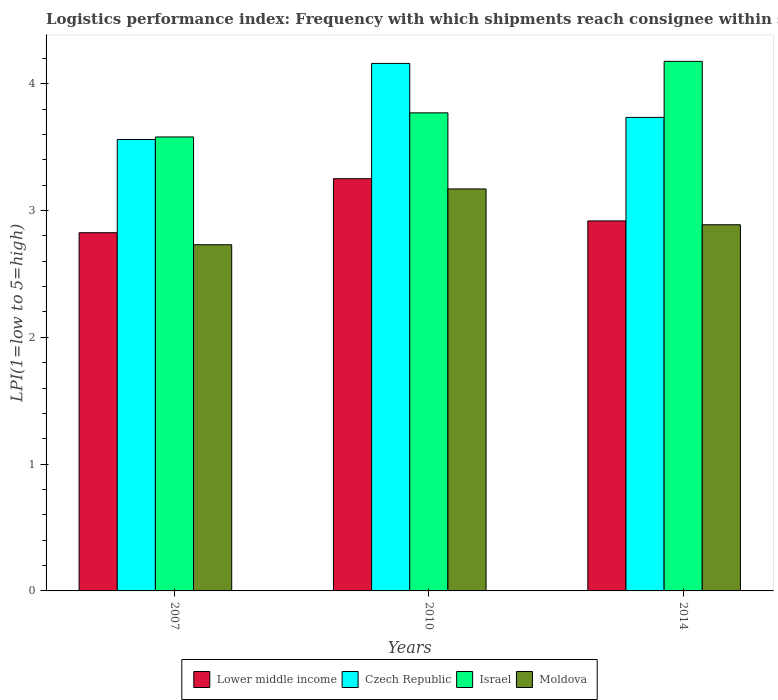How many groups of bars are there?
Your answer should be compact. 3. Are the number of bars per tick equal to the number of legend labels?
Make the answer very short. Yes. Are the number of bars on each tick of the X-axis equal?
Provide a short and direct response. Yes. What is the label of the 1st group of bars from the left?
Offer a terse response. 2007. What is the logistics performance index in Lower middle income in 2014?
Your answer should be compact. 2.92. Across all years, what is the maximum logistics performance index in Lower middle income?
Your response must be concise. 3.25. Across all years, what is the minimum logistics performance index in Czech Republic?
Offer a very short reply. 3.56. In which year was the logistics performance index in Israel minimum?
Your answer should be compact. 2007. What is the total logistics performance index in Lower middle income in the graph?
Offer a very short reply. 8.99. What is the difference between the logistics performance index in Israel in 2007 and that in 2010?
Keep it short and to the point. -0.19. What is the difference between the logistics performance index in Israel in 2007 and the logistics performance index in Lower middle income in 2014?
Offer a very short reply. 0.66. What is the average logistics performance index in Moldova per year?
Ensure brevity in your answer.  2.93. In the year 2014, what is the difference between the logistics performance index in Czech Republic and logistics performance index in Israel?
Provide a short and direct response. -0.44. What is the ratio of the logistics performance index in Israel in 2007 to that in 2014?
Your answer should be very brief. 0.86. Is the logistics performance index in Czech Republic in 2007 less than that in 2014?
Your answer should be very brief. Yes. Is the difference between the logistics performance index in Czech Republic in 2007 and 2014 greater than the difference between the logistics performance index in Israel in 2007 and 2014?
Your answer should be very brief. Yes. What is the difference between the highest and the second highest logistics performance index in Lower middle income?
Ensure brevity in your answer.  0.33. What is the difference between the highest and the lowest logistics performance index in Czech Republic?
Make the answer very short. 0.6. In how many years, is the logistics performance index in Lower middle income greater than the average logistics performance index in Lower middle income taken over all years?
Ensure brevity in your answer.  1. Is it the case that in every year, the sum of the logistics performance index in Czech Republic and logistics performance index in Lower middle income is greater than the sum of logistics performance index in Moldova and logistics performance index in Israel?
Offer a terse response. No. What does the 4th bar from the left in 2007 represents?
Your answer should be compact. Moldova. What does the 3rd bar from the right in 2014 represents?
Provide a succinct answer. Czech Republic. Is it the case that in every year, the sum of the logistics performance index in Israel and logistics performance index in Lower middle income is greater than the logistics performance index in Moldova?
Your response must be concise. Yes. How many bars are there?
Keep it short and to the point. 12. Are all the bars in the graph horizontal?
Offer a terse response. No. How many years are there in the graph?
Your response must be concise. 3. Does the graph contain grids?
Your response must be concise. No. How many legend labels are there?
Your answer should be compact. 4. What is the title of the graph?
Provide a short and direct response. Logistics performance index: Frequency with which shipments reach consignee within scheduled time. Does "Europe(all income levels)" appear as one of the legend labels in the graph?
Ensure brevity in your answer.  No. What is the label or title of the Y-axis?
Your answer should be very brief. LPI(1=low to 5=high). What is the LPI(1=low to 5=high) in Lower middle income in 2007?
Give a very brief answer. 2.82. What is the LPI(1=low to 5=high) of Czech Republic in 2007?
Provide a short and direct response. 3.56. What is the LPI(1=low to 5=high) in Israel in 2007?
Provide a succinct answer. 3.58. What is the LPI(1=low to 5=high) of Moldova in 2007?
Give a very brief answer. 2.73. What is the LPI(1=low to 5=high) of Lower middle income in 2010?
Offer a terse response. 3.25. What is the LPI(1=low to 5=high) in Czech Republic in 2010?
Your response must be concise. 4.16. What is the LPI(1=low to 5=high) of Israel in 2010?
Offer a terse response. 3.77. What is the LPI(1=low to 5=high) in Moldova in 2010?
Your answer should be very brief. 3.17. What is the LPI(1=low to 5=high) of Lower middle income in 2014?
Your response must be concise. 2.92. What is the LPI(1=low to 5=high) of Czech Republic in 2014?
Ensure brevity in your answer.  3.73. What is the LPI(1=low to 5=high) in Israel in 2014?
Your answer should be compact. 4.18. What is the LPI(1=low to 5=high) of Moldova in 2014?
Make the answer very short. 2.89. Across all years, what is the maximum LPI(1=low to 5=high) of Lower middle income?
Make the answer very short. 3.25. Across all years, what is the maximum LPI(1=low to 5=high) of Czech Republic?
Offer a terse response. 4.16. Across all years, what is the maximum LPI(1=low to 5=high) in Israel?
Ensure brevity in your answer.  4.18. Across all years, what is the maximum LPI(1=low to 5=high) of Moldova?
Your answer should be compact. 3.17. Across all years, what is the minimum LPI(1=low to 5=high) of Lower middle income?
Ensure brevity in your answer.  2.82. Across all years, what is the minimum LPI(1=low to 5=high) in Czech Republic?
Provide a short and direct response. 3.56. Across all years, what is the minimum LPI(1=low to 5=high) of Israel?
Your answer should be compact. 3.58. Across all years, what is the minimum LPI(1=low to 5=high) in Moldova?
Your answer should be compact. 2.73. What is the total LPI(1=low to 5=high) in Lower middle income in the graph?
Make the answer very short. 8.99. What is the total LPI(1=low to 5=high) in Czech Republic in the graph?
Your response must be concise. 11.45. What is the total LPI(1=low to 5=high) of Israel in the graph?
Offer a very short reply. 11.53. What is the total LPI(1=low to 5=high) of Moldova in the graph?
Your response must be concise. 8.79. What is the difference between the LPI(1=low to 5=high) in Lower middle income in 2007 and that in 2010?
Make the answer very short. -0.43. What is the difference between the LPI(1=low to 5=high) of Czech Republic in 2007 and that in 2010?
Your answer should be compact. -0.6. What is the difference between the LPI(1=low to 5=high) in Israel in 2007 and that in 2010?
Your response must be concise. -0.19. What is the difference between the LPI(1=low to 5=high) of Moldova in 2007 and that in 2010?
Offer a terse response. -0.44. What is the difference between the LPI(1=low to 5=high) of Lower middle income in 2007 and that in 2014?
Your response must be concise. -0.09. What is the difference between the LPI(1=low to 5=high) in Czech Republic in 2007 and that in 2014?
Keep it short and to the point. -0.17. What is the difference between the LPI(1=low to 5=high) of Israel in 2007 and that in 2014?
Your response must be concise. -0.6. What is the difference between the LPI(1=low to 5=high) of Moldova in 2007 and that in 2014?
Offer a very short reply. -0.16. What is the difference between the LPI(1=low to 5=high) in Lower middle income in 2010 and that in 2014?
Ensure brevity in your answer.  0.33. What is the difference between the LPI(1=low to 5=high) in Czech Republic in 2010 and that in 2014?
Keep it short and to the point. 0.43. What is the difference between the LPI(1=low to 5=high) of Israel in 2010 and that in 2014?
Make the answer very short. -0.41. What is the difference between the LPI(1=low to 5=high) in Moldova in 2010 and that in 2014?
Your answer should be compact. 0.28. What is the difference between the LPI(1=low to 5=high) in Lower middle income in 2007 and the LPI(1=low to 5=high) in Czech Republic in 2010?
Keep it short and to the point. -1.34. What is the difference between the LPI(1=low to 5=high) of Lower middle income in 2007 and the LPI(1=low to 5=high) of Israel in 2010?
Provide a succinct answer. -0.95. What is the difference between the LPI(1=low to 5=high) of Lower middle income in 2007 and the LPI(1=low to 5=high) of Moldova in 2010?
Your answer should be very brief. -0.35. What is the difference between the LPI(1=low to 5=high) of Czech Republic in 2007 and the LPI(1=low to 5=high) of Israel in 2010?
Your answer should be compact. -0.21. What is the difference between the LPI(1=low to 5=high) in Czech Republic in 2007 and the LPI(1=low to 5=high) in Moldova in 2010?
Make the answer very short. 0.39. What is the difference between the LPI(1=low to 5=high) of Israel in 2007 and the LPI(1=low to 5=high) of Moldova in 2010?
Make the answer very short. 0.41. What is the difference between the LPI(1=low to 5=high) of Lower middle income in 2007 and the LPI(1=low to 5=high) of Czech Republic in 2014?
Your response must be concise. -0.91. What is the difference between the LPI(1=low to 5=high) of Lower middle income in 2007 and the LPI(1=low to 5=high) of Israel in 2014?
Your answer should be very brief. -1.35. What is the difference between the LPI(1=low to 5=high) of Lower middle income in 2007 and the LPI(1=low to 5=high) of Moldova in 2014?
Offer a very short reply. -0.06. What is the difference between the LPI(1=low to 5=high) of Czech Republic in 2007 and the LPI(1=low to 5=high) of Israel in 2014?
Provide a succinct answer. -0.62. What is the difference between the LPI(1=low to 5=high) in Czech Republic in 2007 and the LPI(1=low to 5=high) in Moldova in 2014?
Offer a very short reply. 0.67. What is the difference between the LPI(1=low to 5=high) of Israel in 2007 and the LPI(1=low to 5=high) of Moldova in 2014?
Provide a succinct answer. 0.69. What is the difference between the LPI(1=low to 5=high) of Lower middle income in 2010 and the LPI(1=low to 5=high) of Czech Republic in 2014?
Your response must be concise. -0.48. What is the difference between the LPI(1=low to 5=high) of Lower middle income in 2010 and the LPI(1=low to 5=high) of Israel in 2014?
Make the answer very short. -0.93. What is the difference between the LPI(1=low to 5=high) of Lower middle income in 2010 and the LPI(1=low to 5=high) of Moldova in 2014?
Provide a succinct answer. 0.36. What is the difference between the LPI(1=low to 5=high) of Czech Republic in 2010 and the LPI(1=low to 5=high) of Israel in 2014?
Give a very brief answer. -0.02. What is the difference between the LPI(1=low to 5=high) in Czech Republic in 2010 and the LPI(1=low to 5=high) in Moldova in 2014?
Your answer should be compact. 1.27. What is the difference between the LPI(1=low to 5=high) in Israel in 2010 and the LPI(1=low to 5=high) in Moldova in 2014?
Provide a short and direct response. 0.88. What is the average LPI(1=low to 5=high) in Lower middle income per year?
Offer a terse response. 3. What is the average LPI(1=low to 5=high) of Czech Republic per year?
Offer a very short reply. 3.82. What is the average LPI(1=low to 5=high) of Israel per year?
Ensure brevity in your answer.  3.84. What is the average LPI(1=low to 5=high) in Moldova per year?
Your answer should be compact. 2.93. In the year 2007, what is the difference between the LPI(1=low to 5=high) of Lower middle income and LPI(1=low to 5=high) of Czech Republic?
Offer a terse response. -0.74. In the year 2007, what is the difference between the LPI(1=low to 5=high) in Lower middle income and LPI(1=low to 5=high) in Israel?
Give a very brief answer. -0.76. In the year 2007, what is the difference between the LPI(1=low to 5=high) in Lower middle income and LPI(1=low to 5=high) in Moldova?
Make the answer very short. 0.09. In the year 2007, what is the difference between the LPI(1=low to 5=high) of Czech Republic and LPI(1=low to 5=high) of Israel?
Give a very brief answer. -0.02. In the year 2007, what is the difference between the LPI(1=low to 5=high) in Czech Republic and LPI(1=low to 5=high) in Moldova?
Your answer should be very brief. 0.83. In the year 2007, what is the difference between the LPI(1=low to 5=high) of Israel and LPI(1=low to 5=high) of Moldova?
Make the answer very short. 0.85. In the year 2010, what is the difference between the LPI(1=low to 5=high) in Lower middle income and LPI(1=low to 5=high) in Czech Republic?
Your response must be concise. -0.91. In the year 2010, what is the difference between the LPI(1=low to 5=high) of Lower middle income and LPI(1=low to 5=high) of Israel?
Keep it short and to the point. -0.52. In the year 2010, what is the difference between the LPI(1=low to 5=high) in Lower middle income and LPI(1=low to 5=high) in Moldova?
Give a very brief answer. 0.08. In the year 2010, what is the difference between the LPI(1=low to 5=high) of Czech Republic and LPI(1=low to 5=high) of Israel?
Offer a very short reply. 0.39. In the year 2014, what is the difference between the LPI(1=low to 5=high) in Lower middle income and LPI(1=low to 5=high) in Czech Republic?
Keep it short and to the point. -0.82. In the year 2014, what is the difference between the LPI(1=low to 5=high) in Lower middle income and LPI(1=low to 5=high) in Israel?
Offer a very short reply. -1.26. In the year 2014, what is the difference between the LPI(1=low to 5=high) in Lower middle income and LPI(1=low to 5=high) in Moldova?
Your response must be concise. 0.03. In the year 2014, what is the difference between the LPI(1=low to 5=high) in Czech Republic and LPI(1=low to 5=high) in Israel?
Your answer should be very brief. -0.44. In the year 2014, what is the difference between the LPI(1=low to 5=high) in Czech Republic and LPI(1=low to 5=high) in Moldova?
Your response must be concise. 0.85. In the year 2014, what is the difference between the LPI(1=low to 5=high) in Israel and LPI(1=low to 5=high) in Moldova?
Keep it short and to the point. 1.29. What is the ratio of the LPI(1=low to 5=high) of Lower middle income in 2007 to that in 2010?
Provide a succinct answer. 0.87. What is the ratio of the LPI(1=low to 5=high) in Czech Republic in 2007 to that in 2010?
Ensure brevity in your answer.  0.86. What is the ratio of the LPI(1=low to 5=high) in Israel in 2007 to that in 2010?
Make the answer very short. 0.95. What is the ratio of the LPI(1=low to 5=high) of Moldova in 2007 to that in 2010?
Offer a terse response. 0.86. What is the ratio of the LPI(1=low to 5=high) of Lower middle income in 2007 to that in 2014?
Provide a succinct answer. 0.97. What is the ratio of the LPI(1=low to 5=high) in Czech Republic in 2007 to that in 2014?
Offer a terse response. 0.95. What is the ratio of the LPI(1=low to 5=high) of Israel in 2007 to that in 2014?
Provide a short and direct response. 0.86. What is the ratio of the LPI(1=low to 5=high) of Moldova in 2007 to that in 2014?
Give a very brief answer. 0.95. What is the ratio of the LPI(1=low to 5=high) of Lower middle income in 2010 to that in 2014?
Offer a terse response. 1.11. What is the ratio of the LPI(1=low to 5=high) of Czech Republic in 2010 to that in 2014?
Offer a terse response. 1.11. What is the ratio of the LPI(1=low to 5=high) in Israel in 2010 to that in 2014?
Provide a short and direct response. 0.9. What is the ratio of the LPI(1=low to 5=high) in Moldova in 2010 to that in 2014?
Give a very brief answer. 1.1. What is the difference between the highest and the second highest LPI(1=low to 5=high) in Lower middle income?
Offer a very short reply. 0.33. What is the difference between the highest and the second highest LPI(1=low to 5=high) of Czech Republic?
Offer a very short reply. 0.43. What is the difference between the highest and the second highest LPI(1=low to 5=high) in Israel?
Give a very brief answer. 0.41. What is the difference between the highest and the second highest LPI(1=low to 5=high) in Moldova?
Keep it short and to the point. 0.28. What is the difference between the highest and the lowest LPI(1=low to 5=high) of Lower middle income?
Your response must be concise. 0.43. What is the difference between the highest and the lowest LPI(1=low to 5=high) of Israel?
Provide a succinct answer. 0.6. What is the difference between the highest and the lowest LPI(1=low to 5=high) of Moldova?
Your answer should be very brief. 0.44. 